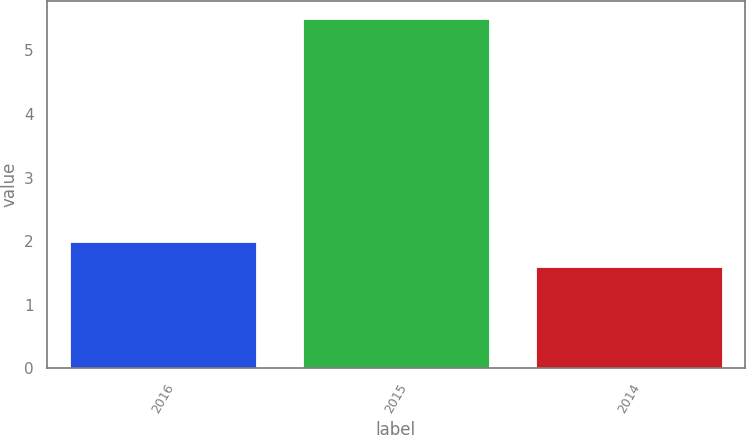<chart> <loc_0><loc_0><loc_500><loc_500><bar_chart><fcel>2016<fcel>2015<fcel>2014<nl><fcel>1.99<fcel>5.5<fcel>1.6<nl></chart> 